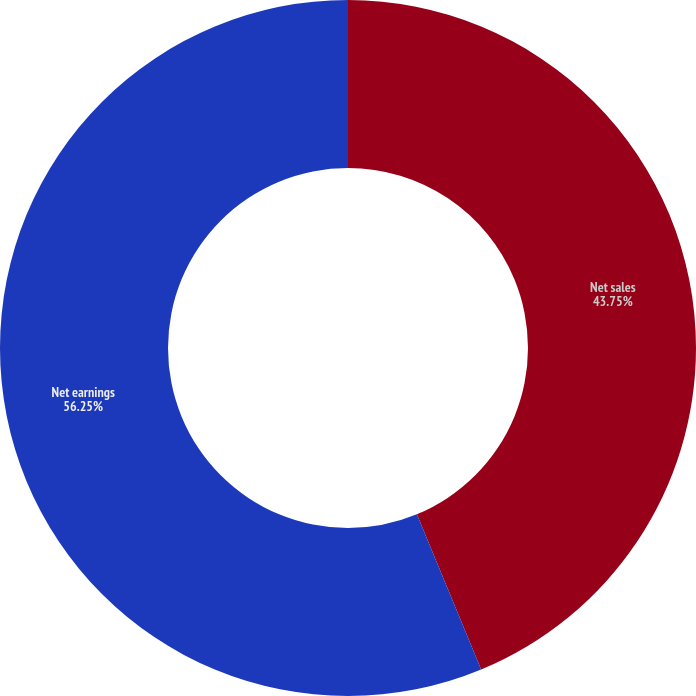<chart> <loc_0><loc_0><loc_500><loc_500><pie_chart><fcel>Net sales<fcel>Net earnings<nl><fcel>43.75%<fcel>56.25%<nl></chart> 